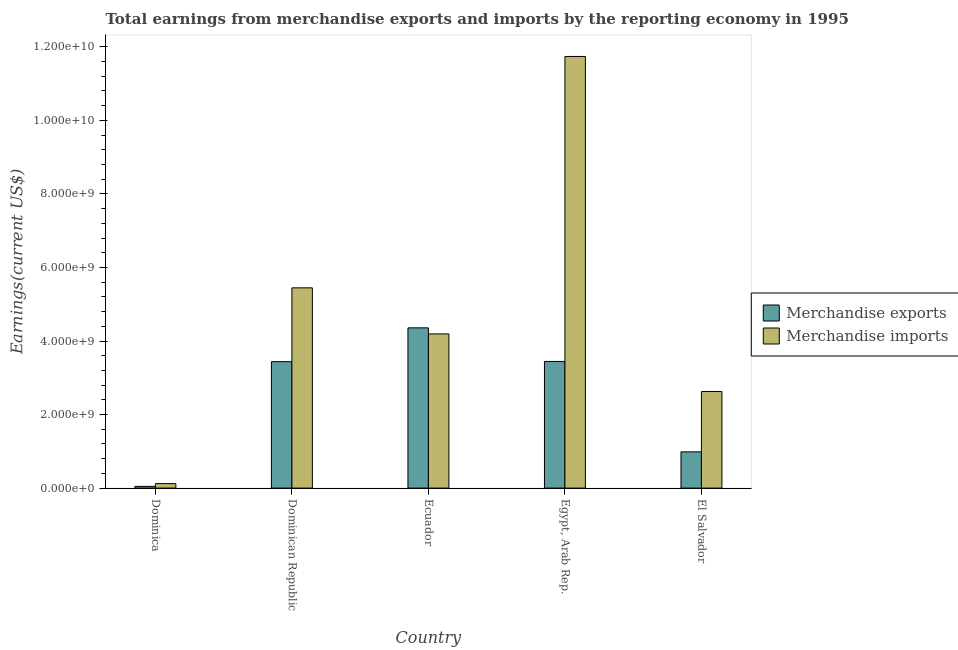How many different coloured bars are there?
Keep it short and to the point. 2. Are the number of bars per tick equal to the number of legend labels?
Make the answer very short. Yes. How many bars are there on the 4th tick from the right?
Ensure brevity in your answer.  2. What is the label of the 5th group of bars from the left?
Make the answer very short. El Salvador. What is the earnings from merchandise imports in El Salvador?
Provide a short and direct response. 2.63e+09. Across all countries, what is the maximum earnings from merchandise exports?
Offer a very short reply. 4.36e+09. Across all countries, what is the minimum earnings from merchandise exports?
Make the answer very short. 4.66e+07. In which country was the earnings from merchandise imports maximum?
Keep it short and to the point. Egypt, Arab Rep. In which country was the earnings from merchandise imports minimum?
Make the answer very short. Dominica. What is the total earnings from merchandise exports in the graph?
Your answer should be very brief. 1.23e+1. What is the difference between the earnings from merchandise imports in Dominican Republic and that in Egypt, Arab Rep.?
Your answer should be compact. -6.29e+09. What is the difference between the earnings from merchandise exports in Ecuador and the earnings from merchandise imports in Dominican Republic?
Provide a succinct answer. -1.09e+09. What is the average earnings from merchandise exports per country?
Your answer should be very brief. 2.45e+09. What is the difference between the earnings from merchandise exports and earnings from merchandise imports in Egypt, Arab Rep.?
Your answer should be compact. -8.29e+09. In how many countries, is the earnings from merchandise imports greater than 1200000000 US$?
Provide a short and direct response. 4. What is the ratio of the earnings from merchandise imports in Dominican Republic to that in Egypt, Arab Rep.?
Offer a terse response. 0.46. What is the difference between the highest and the second highest earnings from merchandise exports?
Make the answer very short. 9.14e+08. What is the difference between the highest and the lowest earnings from merchandise exports?
Provide a short and direct response. 4.31e+09. What does the 2nd bar from the right in Dominica represents?
Provide a short and direct response. Merchandise exports. Are all the bars in the graph horizontal?
Keep it short and to the point. No. What is the difference between two consecutive major ticks on the Y-axis?
Give a very brief answer. 2.00e+09. How many legend labels are there?
Give a very brief answer. 2. What is the title of the graph?
Keep it short and to the point. Total earnings from merchandise exports and imports by the reporting economy in 1995. Does "Taxes" appear as one of the legend labels in the graph?
Provide a short and direct response. No. What is the label or title of the Y-axis?
Make the answer very short. Earnings(current US$). What is the Earnings(current US$) in Merchandise exports in Dominica?
Provide a succinct answer. 4.66e+07. What is the Earnings(current US$) in Merchandise imports in Dominica?
Give a very brief answer. 1.21e+08. What is the Earnings(current US$) of Merchandise exports in Dominican Republic?
Offer a terse response. 3.44e+09. What is the Earnings(current US$) in Merchandise imports in Dominican Republic?
Your response must be concise. 5.45e+09. What is the Earnings(current US$) in Merchandise exports in Ecuador?
Make the answer very short. 4.36e+09. What is the Earnings(current US$) of Merchandise imports in Ecuador?
Make the answer very short. 4.19e+09. What is the Earnings(current US$) in Merchandise exports in Egypt, Arab Rep.?
Provide a short and direct response. 3.44e+09. What is the Earnings(current US$) of Merchandise imports in Egypt, Arab Rep.?
Give a very brief answer. 1.17e+1. What is the Earnings(current US$) of Merchandise exports in El Salvador?
Keep it short and to the point. 9.85e+08. What is the Earnings(current US$) of Merchandise imports in El Salvador?
Offer a terse response. 2.63e+09. Across all countries, what is the maximum Earnings(current US$) of Merchandise exports?
Your answer should be very brief. 4.36e+09. Across all countries, what is the maximum Earnings(current US$) in Merchandise imports?
Your answer should be compact. 1.17e+1. Across all countries, what is the minimum Earnings(current US$) in Merchandise exports?
Your answer should be compact. 4.66e+07. Across all countries, what is the minimum Earnings(current US$) of Merchandise imports?
Make the answer very short. 1.21e+08. What is the total Earnings(current US$) in Merchandise exports in the graph?
Keep it short and to the point. 1.23e+1. What is the total Earnings(current US$) of Merchandise imports in the graph?
Make the answer very short. 2.41e+1. What is the difference between the Earnings(current US$) in Merchandise exports in Dominica and that in Dominican Republic?
Provide a short and direct response. -3.39e+09. What is the difference between the Earnings(current US$) of Merchandise imports in Dominica and that in Dominican Republic?
Offer a very short reply. -5.32e+09. What is the difference between the Earnings(current US$) in Merchandise exports in Dominica and that in Ecuador?
Your response must be concise. -4.31e+09. What is the difference between the Earnings(current US$) of Merchandise imports in Dominica and that in Ecuador?
Your answer should be compact. -4.07e+09. What is the difference between the Earnings(current US$) of Merchandise exports in Dominica and that in Egypt, Arab Rep.?
Give a very brief answer. -3.40e+09. What is the difference between the Earnings(current US$) in Merchandise imports in Dominica and that in Egypt, Arab Rep.?
Offer a terse response. -1.16e+1. What is the difference between the Earnings(current US$) in Merchandise exports in Dominica and that in El Salvador?
Offer a very short reply. -9.39e+08. What is the difference between the Earnings(current US$) in Merchandise imports in Dominica and that in El Salvador?
Your answer should be compact. -2.51e+09. What is the difference between the Earnings(current US$) of Merchandise exports in Dominican Republic and that in Ecuador?
Make the answer very short. -9.19e+08. What is the difference between the Earnings(current US$) in Merchandise imports in Dominican Republic and that in Ecuador?
Offer a terse response. 1.25e+09. What is the difference between the Earnings(current US$) in Merchandise exports in Dominican Republic and that in Egypt, Arab Rep.?
Your response must be concise. -5.66e+06. What is the difference between the Earnings(current US$) of Merchandise imports in Dominican Republic and that in Egypt, Arab Rep.?
Give a very brief answer. -6.29e+09. What is the difference between the Earnings(current US$) in Merchandise exports in Dominican Republic and that in El Salvador?
Make the answer very short. 2.45e+09. What is the difference between the Earnings(current US$) of Merchandise imports in Dominican Republic and that in El Salvador?
Your response must be concise. 2.82e+09. What is the difference between the Earnings(current US$) of Merchandise exports in Ecuador and that in Egypt, Arab Rep.?
Offer a very short reply. 9.14e+08. What is the difference between the Earnings(current US$) of Merchandise imports in Ecuador and that in Egypt, Arab Rep.?
Make the answer very short. -7.55e+09. What is the difference between the Earnings(current US$) in Merchandise exports in Ecuador and that in El Salvador?
Provide a succinct answer. 3.37e+09. What is the difference between the Earnings(current US$) in Merchandise imports in Ecuador and that in El Salvador?
Make the answer very short. 1.57e+09. What is the difference between the Earnings(current US$) of Merchandise exports in Egypt, Arab Rep. and that in El Salvador?
Keep it short and to the point. 2.46e+09. What is the difference between the Earnings(current US$) of Merchandise imports in Egypt, Arab Rep. and that in El Salvador?
Make the answer very short. 9.11e+09. What is the difference between the Earnings(current US$) in Merchandise exports in Dominica and the Earnings(current US$) in Merchandise imports in Dominican Republic?
Keep it short and to the point. -5.40e+09. What is the difference between the Earnings(current US$) of Merchandise exports in Dominica and the Earnings(current US$) of Merchandise imports in Ecuador?
Offer a very short reply. -4.15e+09. What is the difference between the Earnings(current US$) of Merchandise exports in Dominica and the Earnings(current US$) of Merchandise imports in Egypt, Arab Rep.?
Make the answer very short. -1.17e+1. What is the difference between the Earnings(current US$) of Merchandise exports in Dominica and the Earnings(current US$) of Merchandise imports in El Salvador?
Give a very brief answer. -2.58e+09. What is the difference between the Earnings(current US$) of Merchandise exports in Dominican Republic and the Earnings(current US$) of Merchandise imports in Ecuador?
Your response must be concise. -7.55e+08. What is the difference between the Earnings(current US$) in Merchandise exports in Dominican Republic and the Earnings(current US$) in Merchandise imports in Egypt, Arab Rep.?
Keep it short and to the point. -8.30e+09. What is the difference between the Earnings(current US$) in Merchandise exports in Dominican Republic and the Earnings(current US$) in Merchandise imports in El Salvador?
Make the answer very short. 8.11e+08. What is the difference between the Earnings(current US$) in Merchandise exports in Ecuador and the Earnings(current US$) in Merchandise imports in Egypt, Arab Rep.?
Offer a terse response. -7.38e+09. What is the difference between the Earnings(current US$) in Merchandise exports in Ecuador and the Earnings(current US$) in Merchandise imports in El Salvador?
Your answer should be compact. 1.73e+09. What is the difference between the Earnings(current US$) of Merchandise exports in Egypt, Arab Rep. and the Earnings(current US$) of Merchandise imports in El Salvador?
Keep it short and to the point. 8.16e+08. What is the average Earnings(current US$) of Merchandise exports per country?
Give a very brief answer. 2.45e+09. What is the average Earnings(current US$) in Merchandise imports per country?
Offer a very short reply. 4.83e+09. What is the difference between the Earnings(current US$) of Merchandise exports and Earnings(current US$) of Merchandise imports in Dominica?
Keep it short and to the point. -7.48e+07. What is the difference between the Earnings(current US$) of Merchandise exports and Earnings(current US$) of Merchandise imports in Dominican Republic?
Offer a terse response. -2.01e+09. What is the difference between the Earnings(current US$) of Merchandise exports and Earnings(current US$) of Merchandise imports in Ecuador?
Your answer should be very brief. 1.65e+08. What is the difference between the Earnings(current US$) in Merchandise exports and Earnings(current US$) in Merchandise imports in Egypt, Arab Rep.?
Make the answer very short. -8.29e+09. What is the difference between the Earnings(current US$) in Merchandise exports and Earnings(current US$) in Merchandise imports in El Salvador?
Provide a short and direct response. -1.64e+09. What is the ratio of the Earnings(current US$) in Merchandise exports in Dominica to that in Dominican Republic?
Your answer should be compact. 0.01. What is the ratio of the Earnings(current US$) of Merchandise imports in Dominica to that in Dominican Republic?
Your answer should be very brief. 0.02. What is the ratio of the Earnings(current US$) of Merchandise exports in Dominica to that in Ecuador?
Offer a terse response. 0.01. What is the ratio of the Earnings(current US$) of Merchandise imports in Dominica to that in Ecuador?
Your answer should be very brief. 0.03. What is the ratio of the Earnings(current US$) of Merchandise exports in Dominica to that in Egypt, Arab Rep.?
Give a very brief answer. 0.01. What is the ratio of the Earnings(current US$) in Merchandise imports in Dominica to that in Egypt, Arab Rep.?
Give a very brief answer. 0.01. What is the ratio of the Earnings(current US$) in Merchandise exports in Dominica to that in El Salvador?
Your answer should be compact. 0.05. What is the ratio of the Earnings(current US$) in Merchandise imports in Dominica to that in El Salvador?
Your answer should be very brief. 0.05. What is the ratio of the Earnings(current US$) in Merchandise exports in Dominican Republic to that in Ecuador?
Make the answer very short. 0.79. What is the ratio of the Earnings(current US$) in Merchandise imports in Dominican Republic to that in Ecuador?
Offer a very short reply. 1.3. What is the ratio of the Earnings(current US$) in Merchandise exports in Dominican Republic to that in Egypt, Arab Rep.?
Your answer should be compact. 1. What is the ratio of the Earnings(current US$) in Merchandise imports in Dominican Republic to that in Egypt, Arab Rep.?
Offer a terse response. 0.46. What is the ratio of the Earnings(current US$) in Merchandise exports in Dominican Republic to that in El Salvador?
Keep it short and to the point. 3.49. What is the ratio of the Earnings(current US$) in Merchandise imports in Dominican Republic to that in El Salvador?
Your answer should be very brief. 2.07. What is the ratio of the Earnings(current US$) in Merchandise exports in Ecuador to that in Egypt, Arab Rep.?
Your answer should be very brief. 1.27. What is the ratio of the Earnings(current US$) of Merchandise imports in Ecuador to that in Egypt, Arab Rep.?
Your answer should be compact. 0.36. What is the ratio of the Earnings(current US$) of Merchandise exports in Ecuador to that in El Salvador?
Offer a very short reply. 4.42. What is the ratio of the Earnings(current US$) of Merchandise imports in Ecuador to that in El Salvador?
Keep it short and to the point. 1.6. What is the ratio of the Earnings(current US$) in Merchandise exports in Egypt, Arab Rep. to that in El Salvador?
Offer a very short reply. 3.5. What is the ratio of the Earnings(current US$) of Merchandise imports in Egypt, Arab Rep. to that in El Salvador?
Offer a terse response. 4.47. What is the difference between the highest and the second highest Earnings(current US$) in Merchandise exports?
Provide a succinct answer. 9.14e+08. What is the difference between the highest and the second highest Earnings(current US$) of Merchandise imports?
Your answer should be compact. 6.29e+09. What is the difference between the highest and the lowest Earnings(current US$) in Merchandise exports?
Offer a terse response. 4.31e+09. What is the difference between the highest and the lowest Earnings(current US$) in Merchandise imports?
Make the answer very short. 1.16e+1. 